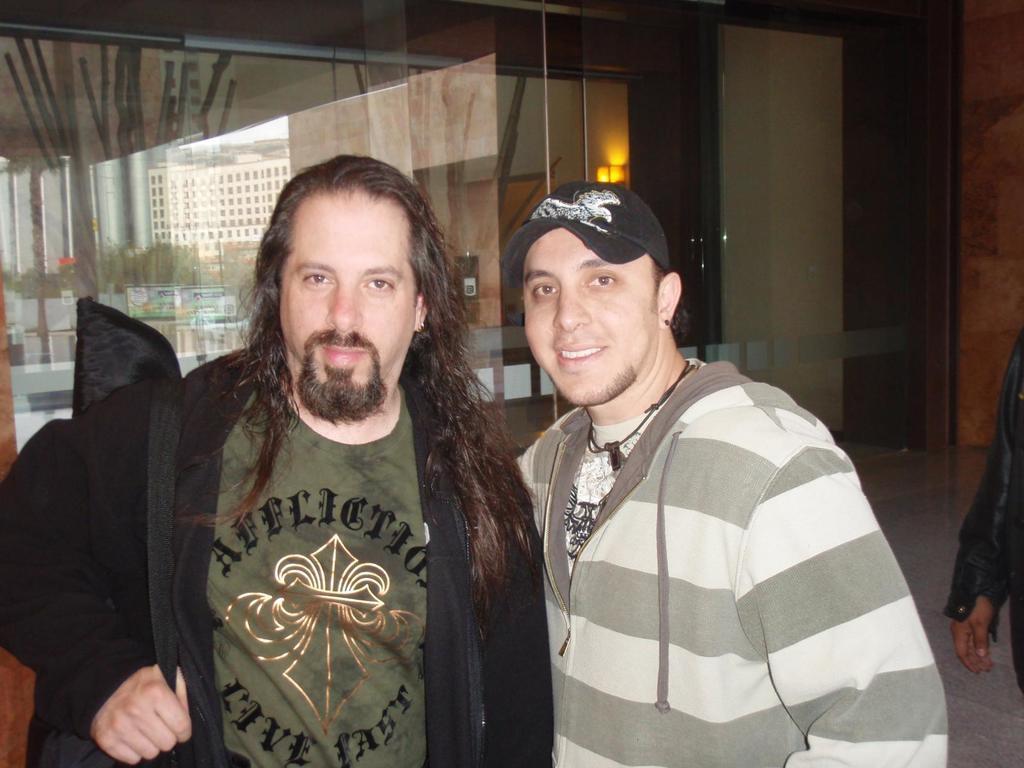Describe this image in one or two sentences. There is a person in black color jacket, wearing a bag and holding thread of the bag, smiling and standing near another person who is smiling and standing. On the right side, there is a person in black color dress. In the background, there is a glass door of a building. On which, there is a mirror image of a building, trees and other objects. 